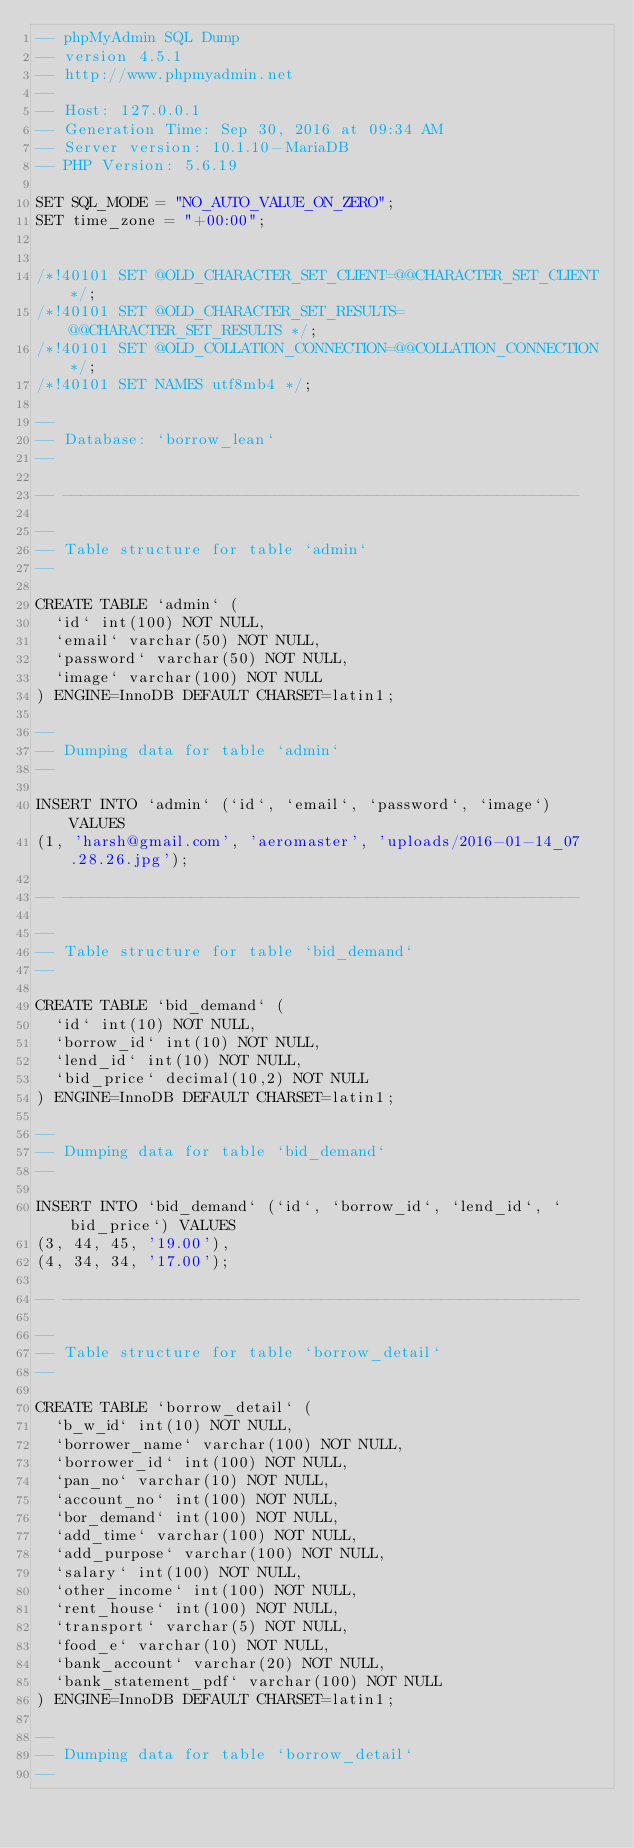<code> <loc_0><loc_0><loc_500><loc_500><_SQL_>-- phpMyAdmin SQL Dump
-- version 4.5.1
-- http://www.phpmyadmin.net
--
-- Host: 127.0.0.1
-- Generation Time: Sep 30, 2016 at 09:34 AM
-- Server version: 10.1.10-MariaDB
-- PHP Version: 5.6.19

SET SQL_MODE = "NO_AUTO_VALUE_ON_ZERO";
SET time_zone = "+00:00";


/*!40101 SET @OLD_CHARACTER_SET_CLIENT=@@CHARACTER_SET_CLIENT */;
/*!40101 SET @OLD_CHARACTER_SET_RESULTS=@@CHARACTER_SET_RESULTS */;
/*!40101 SET @OLD_COLLATION_CONNECTION=@@COLLATION_CONNECTION */;
/*!40101 SET NAMES utf8mb4 */;

--
-- Database: `borrow_lean`
--

-- --------------------------------------------------------

--
-- Table structure for table `admin`
--

CREATE TABLE `admin` (
  `id` int(100) NOT NULL,
  `email` varchar(50) NOT NULL,
  `password` varchar(50) NOT NULL,
  `image` varchar(100) NOT NULL
) ENGINE=InnoDB DEFAULT CHARSET=latin1;

--
-- Dumping data for table `admin`
--

INSERT INTO `admin` (`id`, `email`, `password`, `image`) VALUES
(1, 'harsh@gmail.com', 'aeromaster', 'uploads/2016-01-14_07.28.26.jpg');

-- --------------------------------------------------------

--
-- Table structure for table `bid_demand`
--

CREATE TABLE `bid_demand` (
  `id` int(10) NOT NULL,
  `borrow_id` int(10) NOT NULL,
  `lend_id` int(10) NOT NULL,
  `bid_price` decimal(10,2) NOT NULL
) ENGINE=InnoDB DEFAULT CHARSET=latin1;

--
-- Dumping data for table `bid_demand`
--

INSERT INTO `bid_demand` (`id`, `borrow_id`, `lend_id`, `bid_price`) VALUES
(3, 44, 45, '19.00'),
(4, 34, 34, '17.00');

-- --------------------------------------------------------

--
-- Table structure for table `borrow_detail`
--

CREATE TABLE `borrow_detail` (
  `b_w_id` int(10) NOT NULL,
  `borrower_name` varchar(100) NOT NULL,
  `borrower_id` int(100) NOT NULL,
  `pan_no` varchar(10) NOT NULL,
  `account_no` int(100) NOT NULL,
  `bor_demand` int(100) NOT NULL,
  `add_time` varchar(100) NOT NULL,
  `add_purpose` varchar(100) NOT NULL,
  `salary` int(100) NOT NULL,
  `other_income` int(100) NOT NULL,
  `rent_house` int(100) NOT NULL,
  `transport` varchar(5) NOT NULL,
  `food_e` varchar(10) NOT NULL,
  `bank_account` varchar(20) NOT NULL,
  `bank_statement_pdf` varchar(100) NOT NULL
) ENGINE=InnoDB DEFAULT CHARSET=latin1;

--
-- Dumping data for table `borrow_detail`
--
</code> 